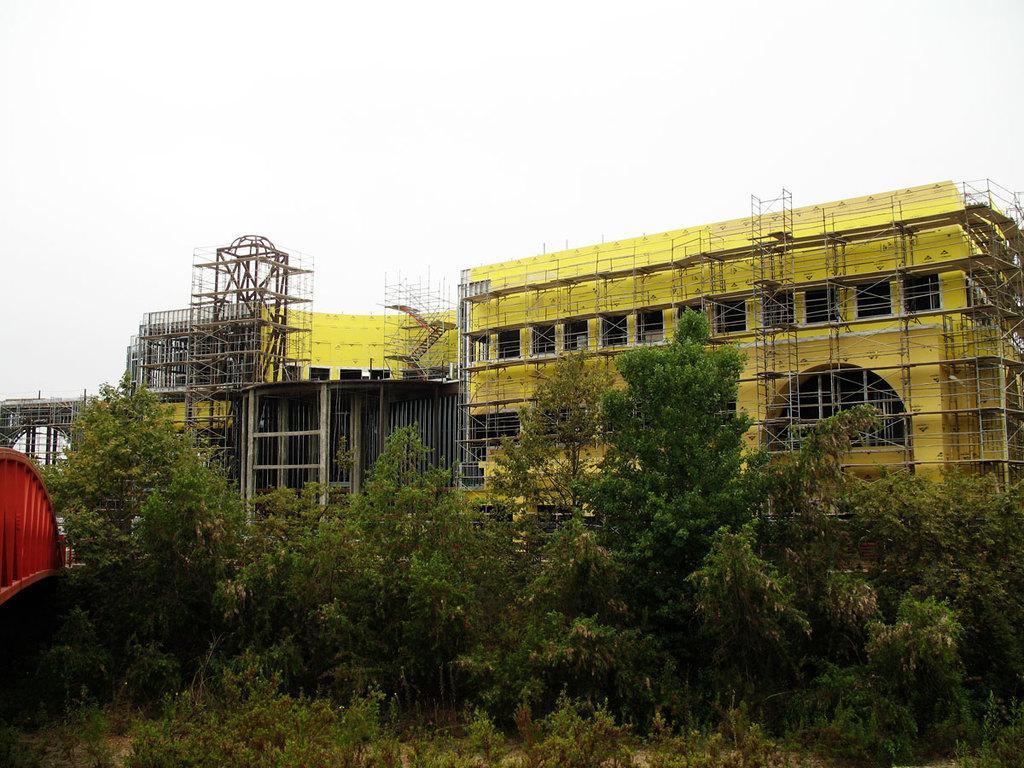Could you give a brief overview of what you see in this image? In this picture there is a building which is yellow in color and there are trees in front of it. 